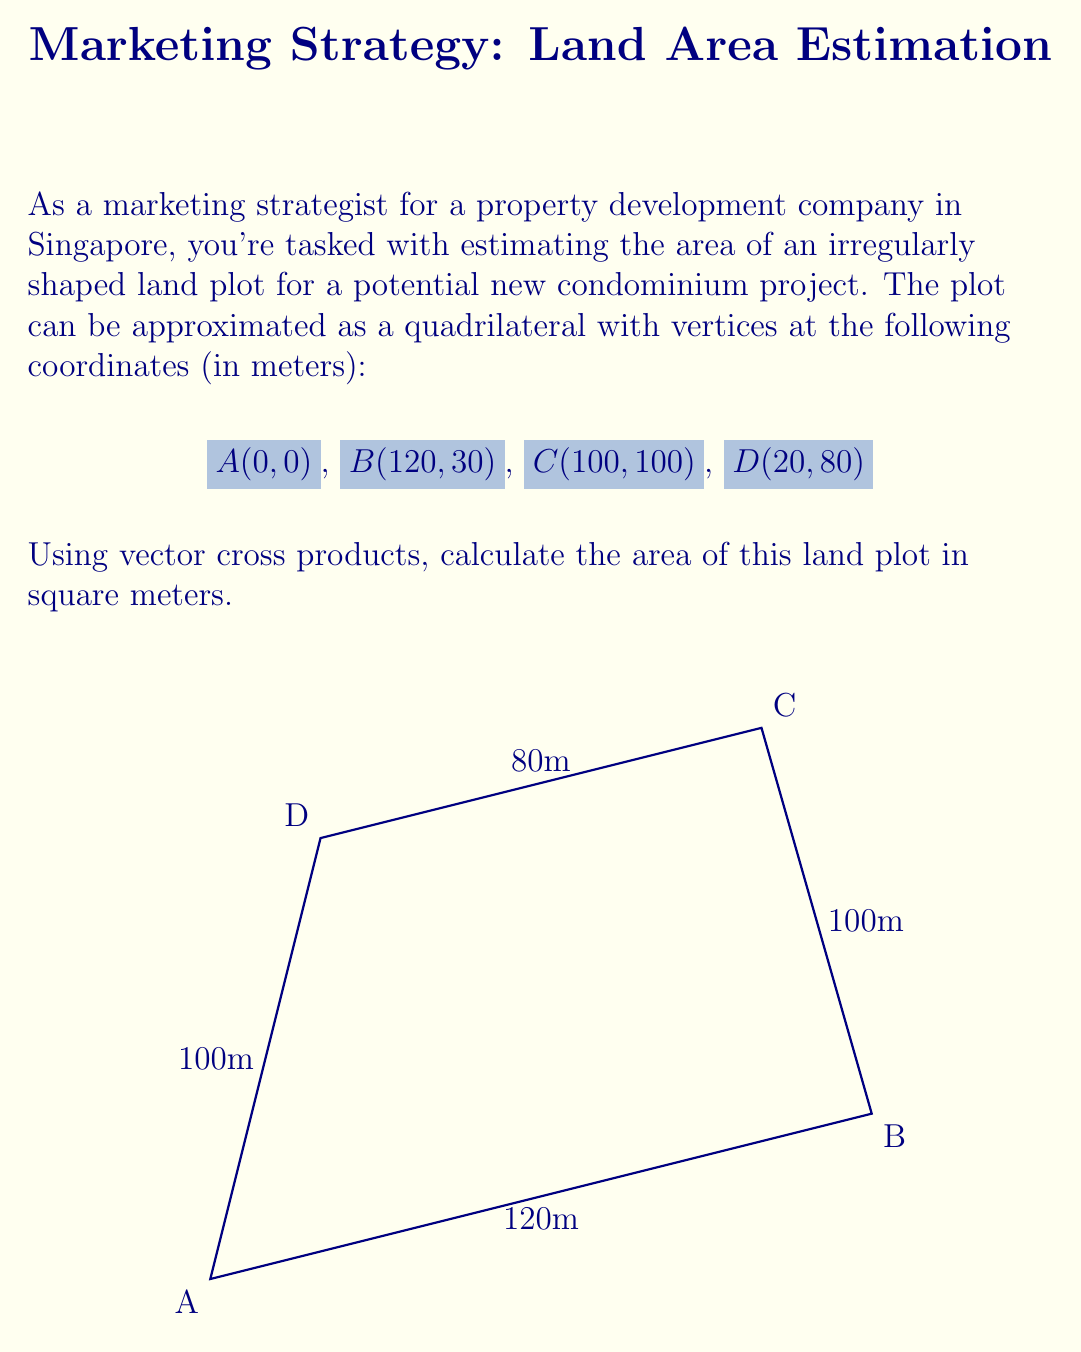What is the answer to this math problem? To solve this problem, we'll use the vector cross product method to calculate the area of the quadrilateral. Here's a step-by-step explanation:

1) First, we need to create two vectors that span the quadrilateral. We'll use vectors from A to C and from B to D.

   $\vec{AC} = (100-0, 100-0) = (100, 100)$
   $\vec{BD} = (20-120, 80-30) = (-100, 50)$

2) The magnitude of the cross product of these vectors will give us twice the area of the quadrilateral. The cross product formula for 2D vectors is:

   $\vec{a} \times \vec{b} = a_x b_y - a_y b_x$

3) Let's calculate the cross product:

   $\vec{AC} \times \vec{BD} = (100 \cdot 50) - (100 \cdot (-100))$
                              $= 5000 + 10000$
                              $= 15000$

4) The magnitude of this cross product is 15000, which represents twice the area of the quadrilateral. To get the actual area, we divide by 2:

   Area = $\frac{|\vec{AC} \times \vec{BD}|}{2} = \frac{15000}{2} = 7500$

Therefore, the area of the land plot is 7500 square meters.
Answer: 7500 m² 